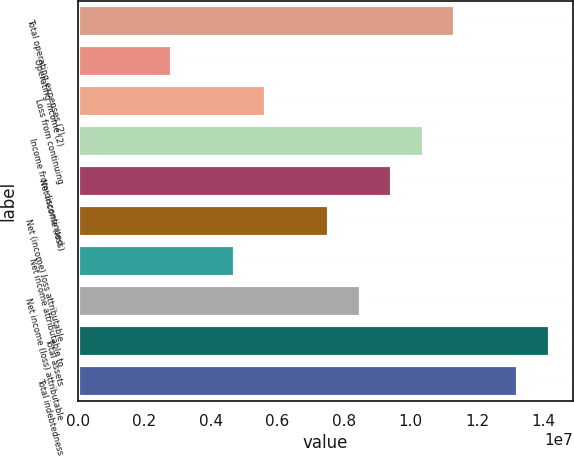Convert chart to OTSL. <chart><loc_0><loc_0><loc_500><loc_500><bar_chart><fcel>Total operating expenses (2)<fcel>Operating income (2)<fcel>Loss from continuing<fcel>Income from discontinued<fcel>Net income (loss)<fcel>Net (income) loss attributable<fcel>Net income attributable to<fcel>Net income (loss) attributable<fcel>Total assets<fcel>Total indebtedness<nl><fcel>1.13489e+07<fcel>2.83723e+06<fcel>5.67446e+06<fcel>1.04032e+07<fcel>9.45742e+06<fcel>7.56594e+06<fcel>4.72871e+06<fcel>8.51168e+06<fcel>1.41861e+07<fcel>1.32404e+07<nl></chart> 